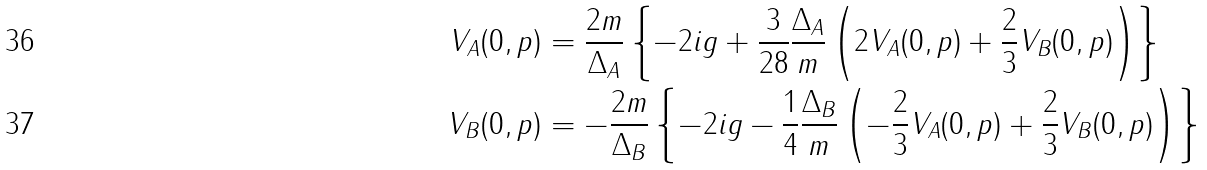Convert formula to latex. <formula><loc_0><loc_0><loc_500><loc_500>V _ { A } ( 0 , p ) & = \frac { 2 m } { \Delta _ { A } } \left \{ - 2 i g + \frac { 3 } { 2 8 } \frac { \Delta _ { A } } { m } \left ( 2 V _ { A } ( 0 , p ) + \frac { 2 } { 3 } V _ { B } ( 0 , p ) \right ) \right \} \\ V _ { B } ( 0 , p ) & = - \frac { 2 m } { \Delta _ { B } } \left \{ - 2 i g - \frac { 1 } { 4 } \frac { \Delta _ { B } } { m } \left ( - \frac { 2 } { 3 } V _ { A } ( 0 , p ) + \frac { 2 } { 3 } V _ { B } ( 0 , p ) \right ) \right \}</formula> 